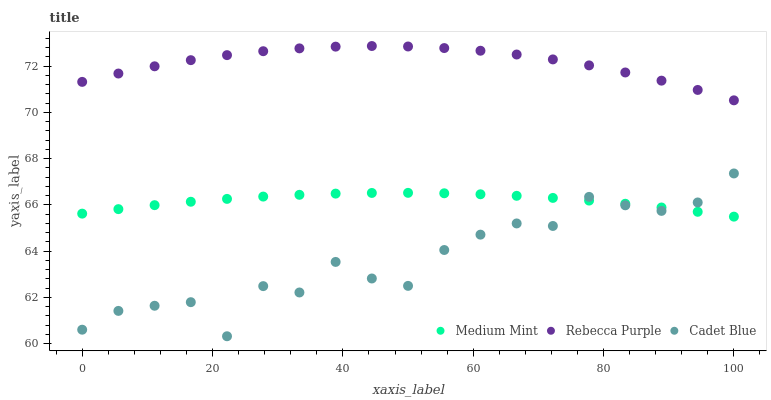Does Cadet Blue have the minimum area under the curve?
Answer yes or no. Yes. Does Rebecca Purple have the maximum area under the curve?
Answer yes or no. Yes. Does Rebecca Purple have the minimum area under the curve?
Answer yes or no. No. Does Cadet Blue have the maximum area under the curve?
Answer yes or no. No. Is Medium Mint the smoothest?
Answer yes or no. Yes. Is Cadet Blue the roughest?
Answer yes or no. Yes. Is Rebecca Purple the smoothest?
Answer yes or no. No. Is Rebecca Purple the roughest?
Answer yes or no. No. Does Cadet Blue have the lowest value?
Answer yes or no. Yes. Does Rebecca Purple have the lowest value?
Answer yes or no. No. Does Rebecca Purple have the highest value?
Answer yes or no. Yes. Does Cadet Blue have the highest value?
Answer yes or no. No. Is Medium Mint less than Rebecca Purple?
Answer yes or no. Yes. Is Rebecca Purple greater than Cadet Blue?
Answer yes or no. Yes. Does Cadet Blue intersect Medium Mint?
Answer yes or no. Yes. Is Cadet Blue less than Medium Mint?
Answer yes or no. No. Is Cadet Blue greater than Medium Mint?
Answer yes or no. No. Does Medium Mint intersect Rebecca Purple?
Answer yes or no. No. 